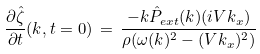<formula> <loc_0><loc_0><loc_500><loc_500>\frac { \partial \hat { \zeta } } { \partial t } ( k , t = 0 ) \, = \, \frac { - k \hat { P } _ { e x t } ( k ) ( i V k _ { x } ) } { \rho ( \omega ( k ) ^ { 2 } - ( V k _ { x } ) ^ { 2 } ) }</formula> 